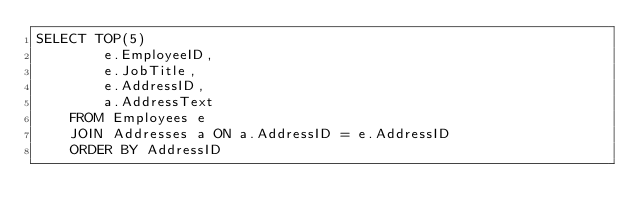<code> <loc_0><loc_0><loc_500><loc_500><_SQL_>SELECT TOP(5) 
		e.EmployeeID, 
		e.JobTitle, 
		e.AddressID, 
		a.AddressText
	FROM Employees e
	JOIN Addresses a ON a.AddressID = e.AddressID
	ORDER BY AddressID
</code> 